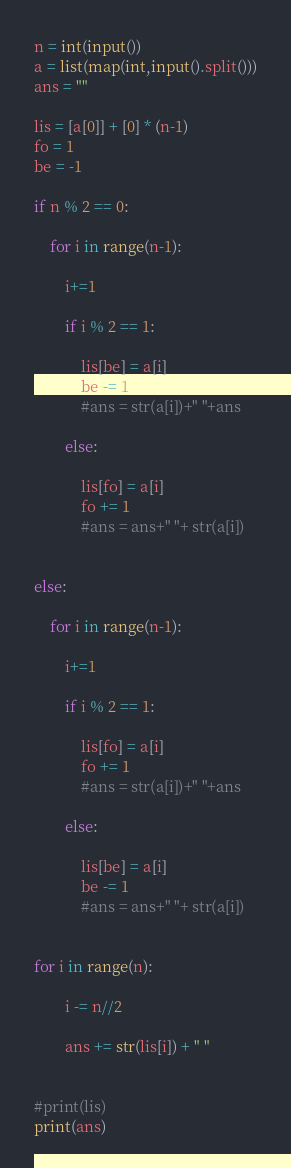<code> <loc_0><loc_0><loc_500><loc_500><_Python_>
n = int(input())
a = list(map(int,input().split()))
ans = ""

lis = [a[0]] + [0] * (n-1)
fo = 1
be = -1

if n % 2 == 0:

    for i in range(n-1):

        i+=1

        if i % 2 == 1:

            lis[be] = a[i]
            be -= 1
            #ans = str(a[i])+" "+ans

        else:

            lis[fo] = a[i]
            fo += 1
            #ans = ans+" "+ str(a[i])


else:

    for i in range(n-1):

        i+=1

        if i % 2 == 1:
            
            lis[fo] = a[i]
            fo += 1
            #ans = str(a[i])+" "+ans

        else:
            
            lis[be] = a[i]
            be -= 1
            #ans = ans+" "+ str(a[i])

            
for i in range(n):

        i -= n//2

        ans += str(lis[i]) + " "


#print(lis)
print(ans)
</code> 